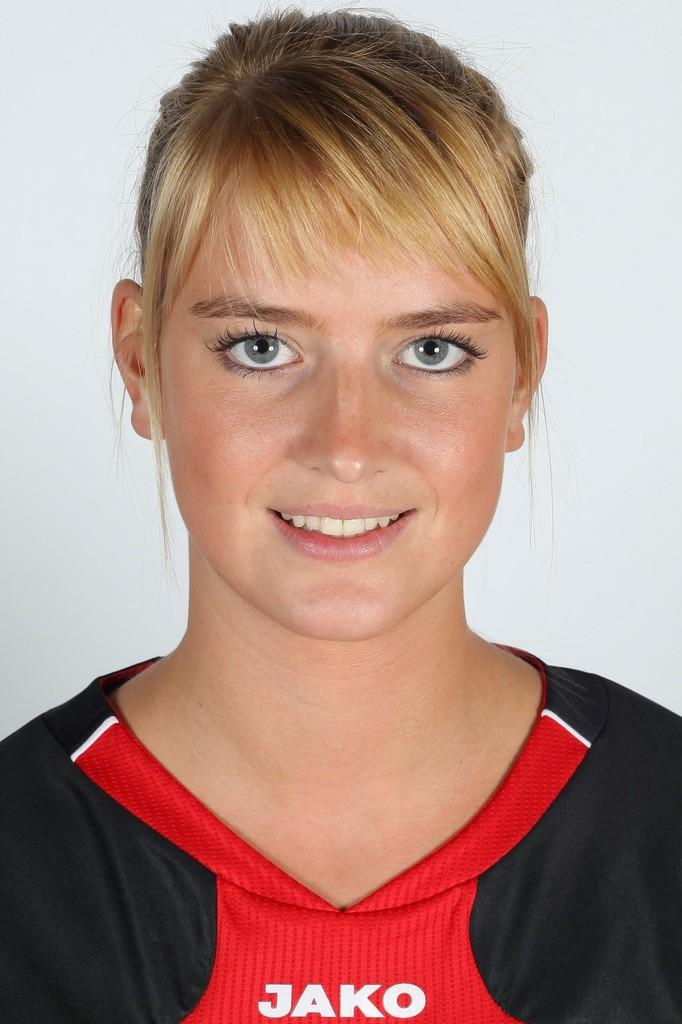<image>
Render a clear and concise summary of the photo. A young lady looks at the camera and wears a red and black top with JAKO on it. 